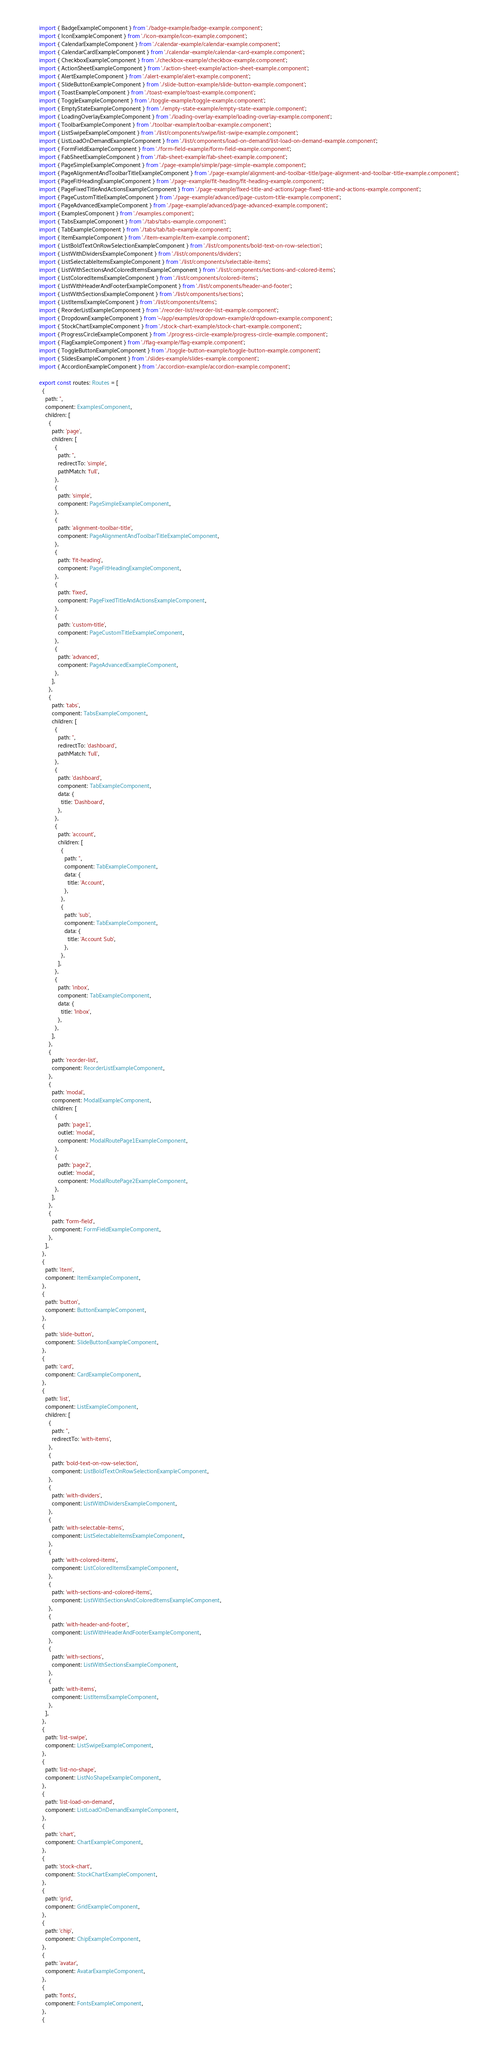Convert code to text. <code><loc_0><loc_0><loc_500><loc_500><_TypeScript_>import { BadgeExampleComponent } from './badge-example/badge-example.component';
import { IconExampleComponent } from './icon-example/icon-example.component';
import { CalendarExampleComponent } from './calendar-example/calendar-example.component';
import { CalendarCardExampleComponent } from './calendar-example/calendar-card-example.component';
import { CheckboxExampleComponent } from './checkbox-example/checkbox-example.component';
import { ActionSheetExampleComponent } from './action-sheet-example/action-sheet-example.component';
import { AlertExampleComponent } from './alert-example/alert-example.component';
import { SlideButtonExampleComponent } from './slide-button-example/slide-button-example.component';
import { ToastExampleComponent } from './toast-example/toast-example.component';
import { ToggleExampleComponent } from './toggle-example/toggle-example.component';
import { EmptyStateExampleComponent } from './empty-state-example/empty-state-example.component';
import { LoadingOverlayExampleComponent } from './loading-overlay-example/loading-overlay-example.component';
import { ToolbarExampleComponent } from './toolbar-example/toolbar-example.component';
import { ListSwipeExampleComponent } from './list/components/swipe/list-swipe-example.component';
import { ListLoadOnDemandExampleComponent } from './list/components/load-on-demand/list-load-on-demand-example.component';
import { FormFieldExampleComponent } from './form-field-example/form-field-example.component';
import { FabSheetExampleComponent } from './fab-sheet-example/fab-sheet-example.component';
import { PageSimpleExampleComponent } from './page-example/simple/page-simple-example.component';
import { PageAlignmentAndToolbarTitleExampleComponent } from './page-example/alignment-and-toolbar-title/page-alignment-and-toolbar-title-example.component';
import { PageFitHeadingExampleComponent } from './page-example/fit-heading/fit-heading-example.component';
import { PageFixedTitleAndActionsExampleComponent } from './page-example/fixed-title-and-actions/page-fixed-title-and-actions-example.component';
import { PageCustomTitleExampleComponent } from './page-example/advanced/page-custom-title-example.component';
import { PageAdvancedExampleComponent } from './page-example/advanced/page-advanced-example.component';
import { ExamplesComponent } from './examples.component';
import { TabsExampleComponent } from './tabs/tabs-example.component';
import { TabExampleComponent } from './tabs/tab/tab-example.component';
import { ItemExampleComponent } from './item-example/item-example.component';
import { ListBoldTextOnRowSelectionExampleComponent } from './list/components/bold-text-on-row-selection';
import { ListWithDividersExampleComponent } from './list/components/dividers';
import { ListSelectableItemsExampleComponent } from './list/components/selectable-items';
import { ListWithSectionsAndColoredItemsExampleComponent } from './list/components/sections-and-colored-items';
import { ListColoredItemsExampleComponent } from './list/components/colored-items';
import { ListWithHeaderAndFooterExampleComponent } from './list/components/header-and-footer';
import { ListWithSectionsExampleComponent } from './list/components/sections';
import { ListItemsExampleComponent } from './list/components/items';
import { ReorderListExampleComponent } from './reorder-list/reorder-list-example.component';
import { DropdownExampleComponent } from '~/app/examples/dropdown-example/dropdown-example.component';
import { StockChartExampleComponent } from './stock-chart-example/stock-chart-example.component';
import { ProgressCircleExampleComponent } from './progress-circle-example/progress-circle-example.component';
import { FlagExampleComponent } from './flag-example/flag-example.component';
import { ToggleButtonExampleComponent } from './toggle-button-example/toggle-button-example.component';
import { SlidesExampleComponent } from './slides-example/slides-example.component';
import { AccordionExampleComponent } from './accordion-example/accordion-example.component';

export const routes: Routes = [
  {
    path: '',
    component: ExamplesComponent,
    children: [
      {
        path: 'page',
        children: [
          {
            path: '',
            redirectTo: 'simple',
            pathMatch: 'full',
          },
          {
            path: 'simple',
            component: PageSimpleExampleComponent,
          },
          {
            path: 'alignment-toolbar-title',
            component: PageAlignmentAndToolbarTitleExampleComponent,
          },
          {
            path: 'fit-heading',
            component: PageFitHeadingExampleComponent,
          },
          {
            path: 'fixed',
            component: PageFixedTitleAndActionsExampleComponent,
          },
          {
            path: 'custom-title',
            component: PageCustomTitleExampleComponent,
          },
          {
            path: 'advanced',
            component: PageAdvancedExampleComponent,
          },
        ],
      },
      {
        path: 'tabs',
        component: TabsExampleComponent,
        children: [
          {
            path: '',
            redirectTo: 'dashboard',
            pathMatch: 'full',
          },
          {
            path: 'dashboard',
            component: TabExampleComponent,
            data: {
              title: 'Dashboard',
            },
          },
          {
            path: 'account',
            children: [
              {
                path: '',
                component: TabExampleComponent,
                data: {
                  title: 'Account',
                },
              },
              {
                path: 'sub',
                component: TabExampleComponent,
                data: {
                  title: 'Account Sub',
                },
              },
            ],
          },
          {
            path: 'inbox',
            component: TabExampleComponent,
            data: {
              title: 'Inbox',
            },
          },
        ],
      },
      {
        path: 'reorder-list',
        component: ReorderListExampleComponent,
      },
      {
        path: 'modal',
        component: ModalExampleComponent,
        children: [
          {
            path: 'page1',
            outlet: 'modal',
            component: ModalRoutePage1ExampleComponent,
          },
          {
            path: 'page2',
            outlet: 'modal',
            component: ModalRoutePage2ExampleComponent,
          },
        ],
      },
      {
        path: 'form-field',
        component: FormFieldExampleComponent,
      },
    ],
  },
  {
    path: 'item',
    component: ItemExampleComponent,
  },
  {
    path: 'button',
    component: ButtonExampleComponent,
  },
  {
    path: 'slide-button',
    component: SlideButtonExampleComponent,
  },
  {
    path: 'card',
    component: CardExampleComponent,
  },
  {
    path: 'list',
    component: ListExampleComponent,
    children: [
      {
        path: '',
        redirectTo: 'with-items',
      },
      {
        path: 'bold-text-on-row-selection',
        component: ListBoldTextOnRowSelectionExampleComponent,
      },
      {
        path: 'with-dividers',
        component: ListWithDividersExampleComponent,
      },
      {
        path: 'with-selectable-items',
        component: ListSelectableItemsExampleComponent,
      },
      {
        path: 'with-colored-items',
        component: ListColoredItemsExampleComponent,
      },
      {
        path: 'with-sections-and-colored-items',
        component: ListWithSectionsAndColoredItemsExampleComponent,
      },
      {
        path: 'with-header-and-footer',
        component: ListWithHeaderAndFooterExampleComponent,
      },
      {
        path: 'with-sections',
        component: ListWithSectionsExampleComponent,
      },
      {
        path: 'with-items',
        component: ListItemsExampleComponent,
      },
    ],
  },
  {
    path: 'list-swipe',
    component: ListSwipeExampleComponent,
  },
  {
    path: 'list-no-shape',
    component: ListNoShapeExampleComponent,
  },
  {
    path: 'list-load-on-demand',
    component: ListLoadOnDemandExampleComponent,
  },
  {
    path: 'chart',
    component: ChartExampleComponent,
  },
  {
    path: 'stock-chart',
    component: StockChartExampleComponent,
  },
  {
    path: 'grid',
    component: GridExampleComponent,
  },
  {
    path: 'chip',
    component: ChipExampleComponent,
  },
  {
    path: 'avatar',
    component: AvatarExampleComponent,
  },
  {
    path: 'fonts',
    component: FontsExampleComponent,
  },
  {</code> 